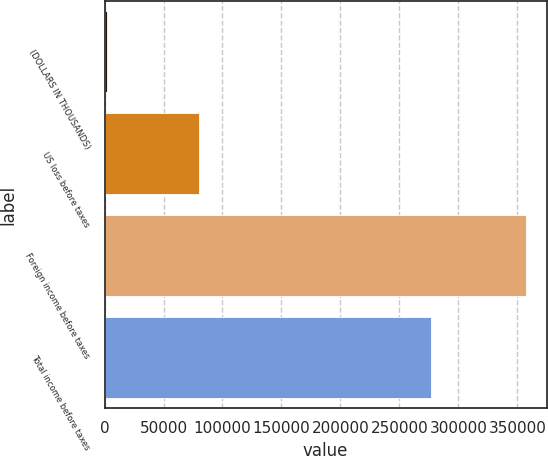Convert chart to OTSL. <chart><loc_0><loc_0><loc_500><loc_500><bar_chart><fcel>(DOLLARS IN THOUSANDS)<fcel>US loss before taxes<fcel>Foreign income before taxes<fcel>Total income before taxes<nl><fcel>2009<fcel>80345<fcel>356894<fcel>276549<nl></chart> 